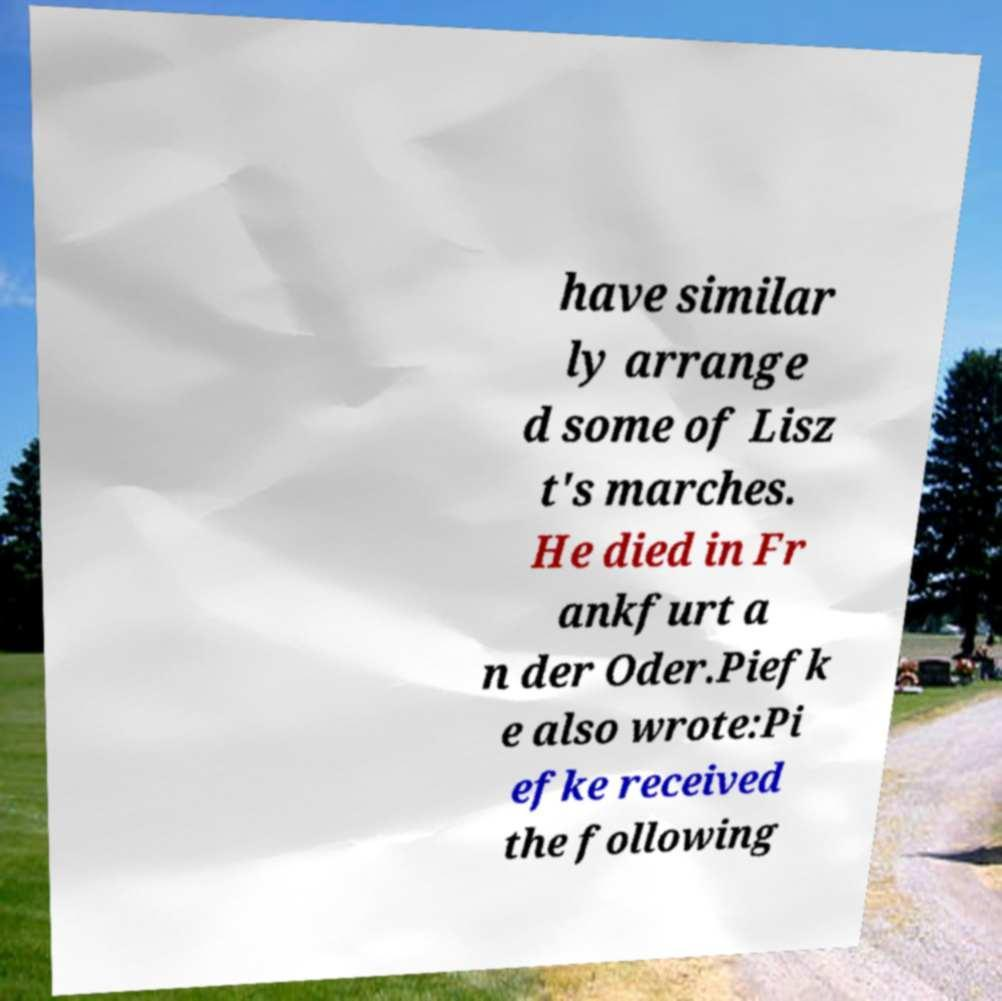Can you accurately transcribe the text from the provided image for me? have similar ly arrange d some of Lisz t's marches. He died in Fr ankfurt a n der Oder.Piefk e also wrote:Pi efke received the following 